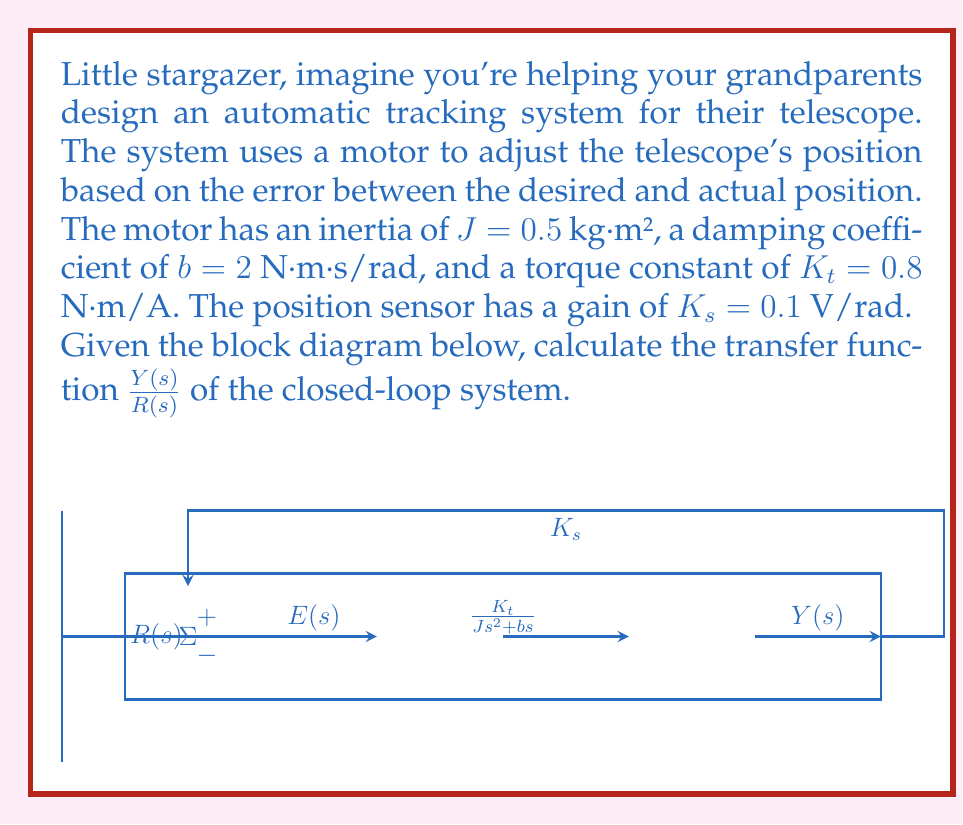Can you solve this math problem? Let's solve this step-by-step:

1) First, we need to identify the forward path transfer function $G(s)$ and the feedback path transfer function $H(s)$.

   $G(s) = \frac{K_t}{Js^2 + bs}$
   $H(s) = K_s$

2) Substitute the given values:
   
   $G(s) = \frac{0.8}{0.5s^2 + 2s} = \frac{1.6}{s^2 + 4s}$
   $H(s) = 0.1$

3) The closed-loop transfer function is given by:

   $$\frac{Y(s)}{R(s)} = \frac{G(s)}{1 + G(s)H(s)}$$

4) Substitute $G(s)$ and $H(s)$:

   $$\frac{Y(s)}{R(s)} = \frac{\frac{1.6}{s^2 + 4s}}{1 + \frac{1.6}{s^2 + 4s} \cdot 0.1}$$

5) Simplify the denominator:

   $$\frac{Y(s)}{R(s)} = \frac{\frac{1.6}{s^2 + 4s}}{\frac{s^2 + 4s + 0.16}{s^2 + 4s}}$$

6) Cancel out $(s^2 + 4s)$ in numerator and denominator:

   $$\frac{Y(s)}{R(s)} = \frac{1.6}{s^2 + 4s + 0.16}$$

7) This is our final closed-loop transfer function.
Answer: $$\frac{Y(s)}{R(s)} = \frac{1.6}{s^2 + 4s + 0.16}$$ 